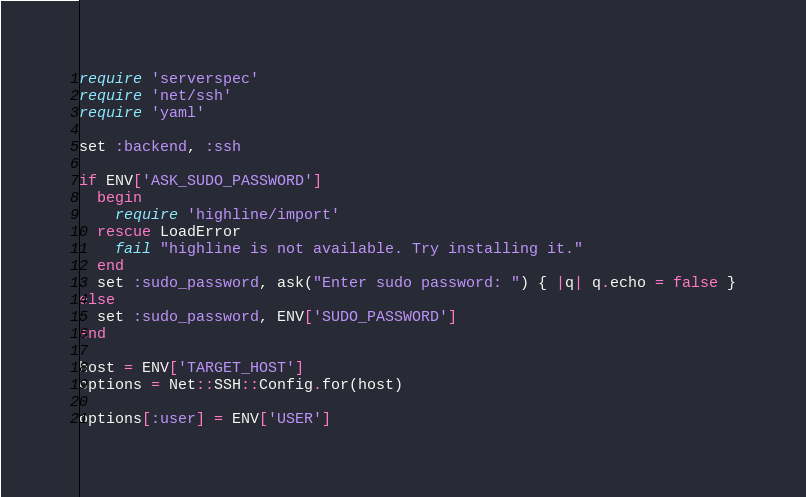<code> <loc_0><loc_0><loc_500><loc_500><_Ruby_>require 'serverspec'
require 'net/ssh'
require 'yaml'

set :backend, :ssh

if ENV['ASK_SUDO_PASSWORD']
  begin
    require 'highline/import'
  rescue LoadError
    fail "highline is not available. Try installing it."
  end
  set :sudo_password, ask("Enter sudo password: ") { |q| q.echo = false }
else
  set :sudo_password, ENV['SUDO_PASSWORD']
end

host = ENV['TARGET_HOST']
options = Net::SSH::Config.for(host)

options[:user] = ENV['USER']</code> 